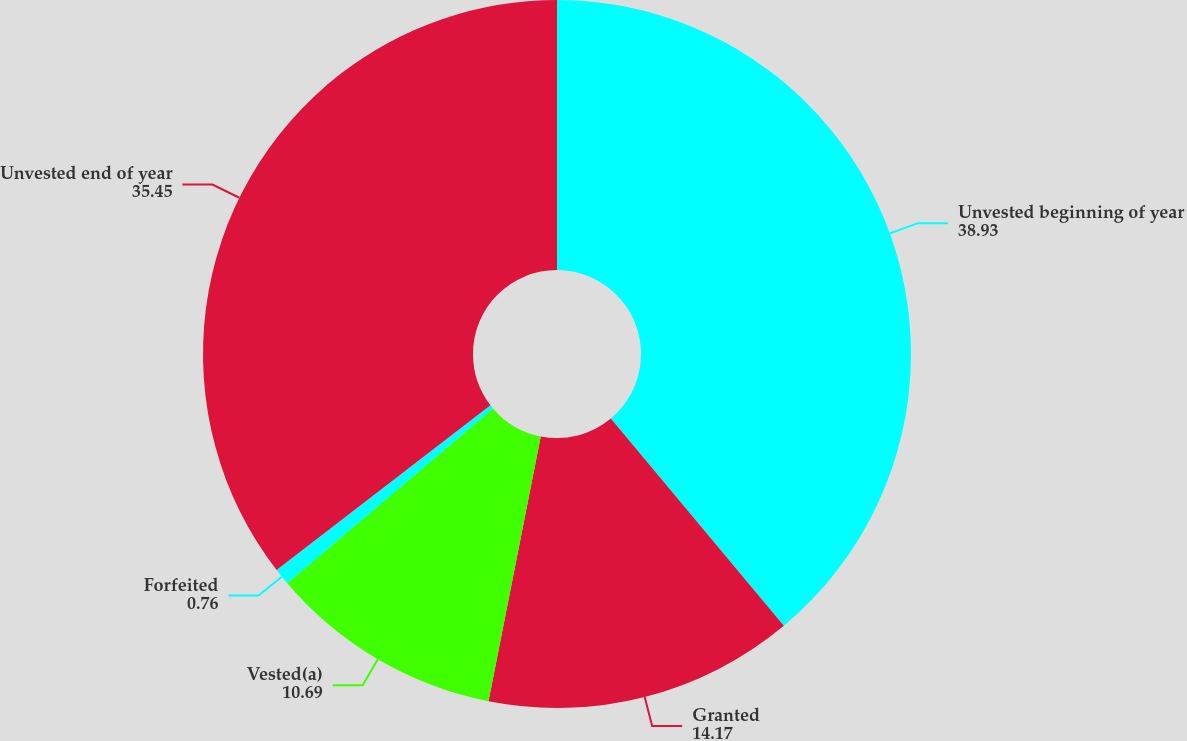Convert chart to OTSL. <chart><loc_0><loc_0><loc_500><loc_500><pie_chart><fcel>Unvested beginning of year<fcel>Granted<fcel>Vested(a)<fcel>Forfeited<fcel>Unvested end of year<nl><fcel>38.93%<fcel>14.17%<fcel>10.69%<fcel>0.76%<fcel>35.45%<nl></chart> 